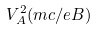<formula> <loc_0><loc_0><loc_500><loc_500>V _ { A } ^ { 2 } ( m c / e B )</formula> 